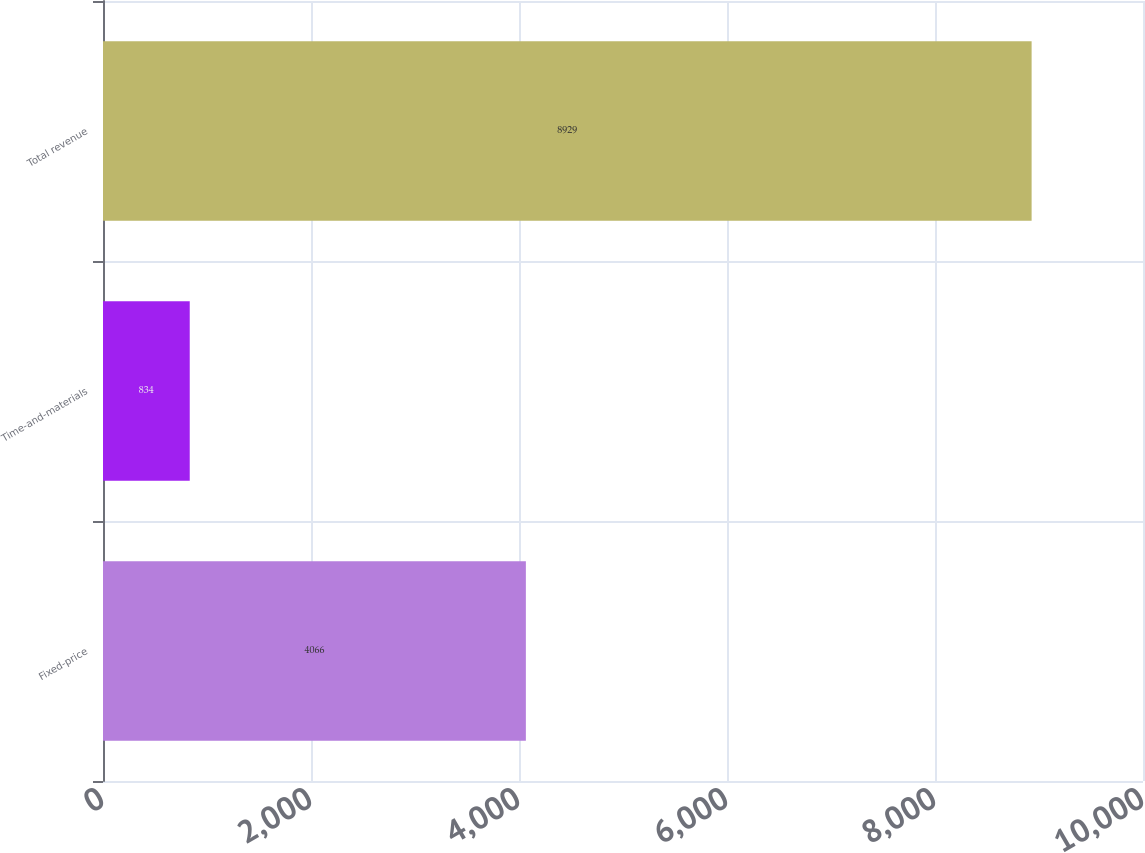Convert chart to OTSL. <chart><loc_0><loc_0><loc_500><loc_500><bar_chart><fcel>Fixed-price<fcel>Time-and-materials<fcel>Total revenue<nl><fcel>4066<fcel>834<fcel>8929<nl></chart> 